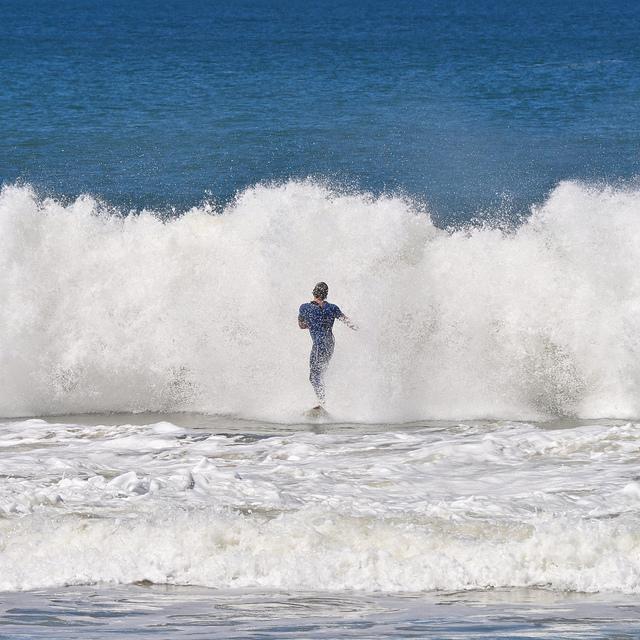How many umbrellas have more than 4 colors?
Give a very brief answer. 0. 